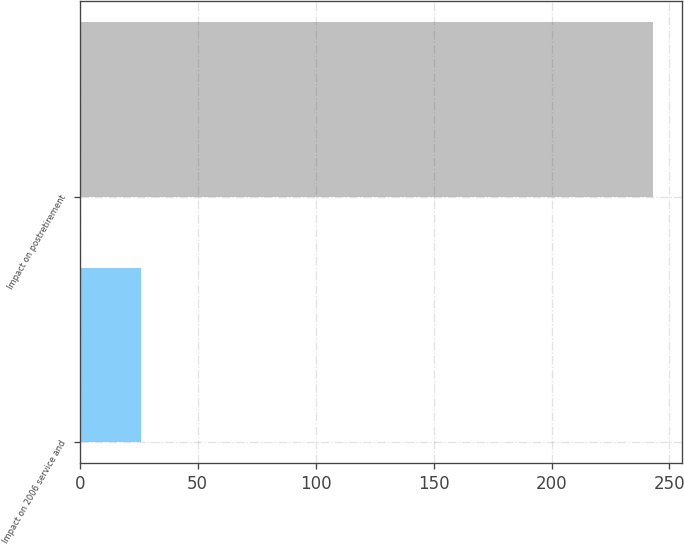Convert chart. <chart><loc_0><loc_0><loc_500><loc_500><bar_chart><fcel>Impact on 2006 service and<fcel>Impact on postretirement<nl><fcel>26<fcel>243<nl></chart> 